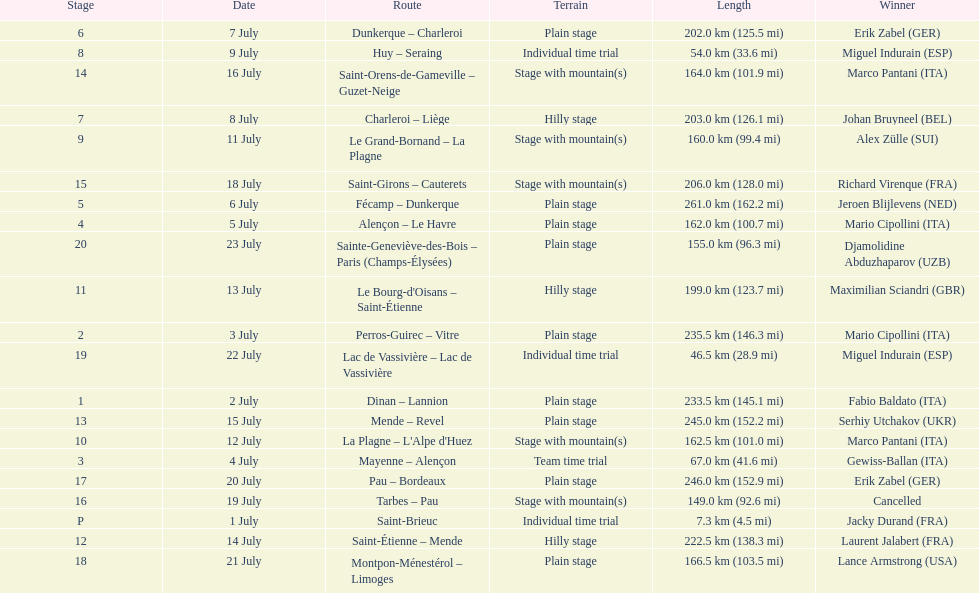How many stages were at least 200 km in length in the 1995 tour de france? 9. 